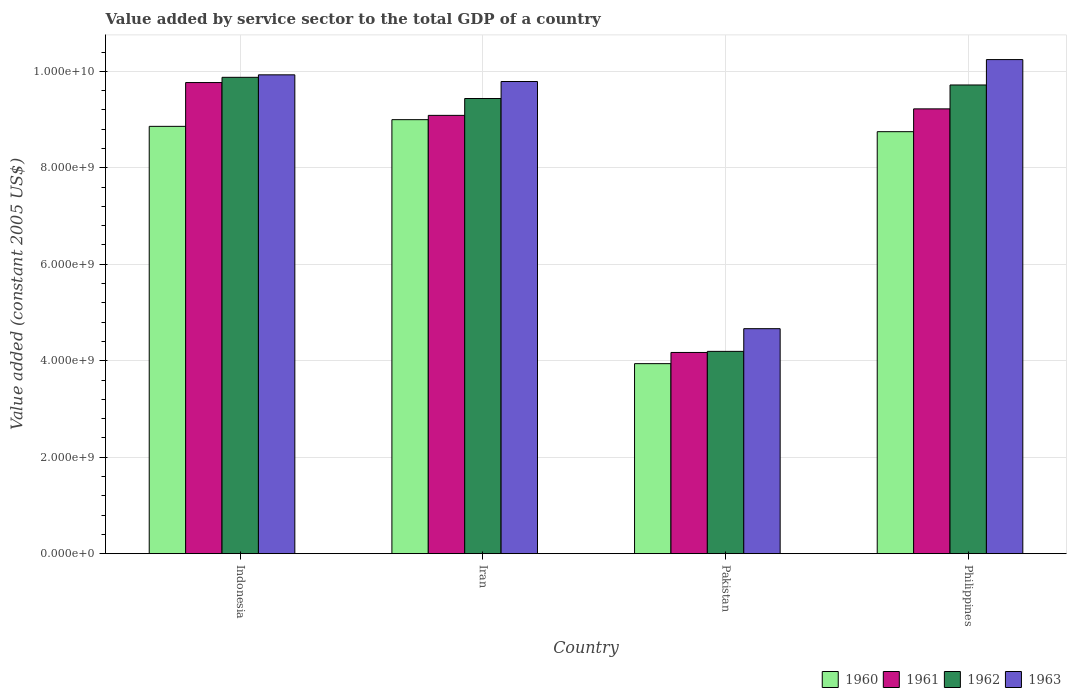How many different coloured bars are there?
Give a very brief answer. 4. How many groups of bars are there?
Your response must be concise. 4. Are the number of bars on each tick of the X-axis equal?
Your answer should be compact. Yes. How many bars are there on the 2nd tick from the left?
Provide a short and direct response. 4. How many bars are there on the 2nd tick from the right?
Offer a terse response. 4. What is the value added by service sector in 1962 in Iran?
Ensure brevity in your answer.  9.44e+09. Across all countries, what is the maximum value added by service sector in 1963?
Ensure brevity in your answer.  1.02e+1. Across all countries, what is the minimum value added by service sector in 1962?
Make the answer very short. 4.19e+09. What is the total value added by service sector in 1962 in the graph?
Offer a terse response. 3.32e+1. What is the difference between the value added by service sector in 1961 in Pakistan and that in Philippines?
Offer a very short reply. -5.05e+09. What is the difference between the value added by service sector in 1960 in Iran and the value added by service sector in 1961 in Pakistan?
Give a very brief answer. 4.83e+09. What is the average value added by service sector in 1960 per country?
Your response must be concise. 7.64e+09. What is the difference between the value added by service sector of/in 1961 and value added by service sector of/in 1960 in Indonesia?
Your answer should be very brief. 9.08e+08. What is the ratio of the value added by service sector in 1961 in Pakistan to that in Philippines?
Ensure brevity in your answer.  0.45. Is the value added by service sector in 1961 in Indonesia less than that in Iran?
Keep it short and to the point. No. Is the difference between the value added by service sector in 1961 in Indonesia and Pakistan greater than the difference between the value added by service sector in 1960 in Indonesia and Pakistan?
Offer a terse response. Yes. What is the difference between the highest and the second highest value added by service sector in 1962?
Your answer should be compact. 2.80e+08. What is the difference between the highest and the lowest value added by service sector in 1962?
Offer a terse response. 5.68e+09. Is the sum of the value added by service sector in 1961 in Iran and Pakistan greater than the maximum value added by service sector in 1963 across all countries?
Make the answer very short. Yes. Is it the case that in every country, the sum of the value added by service sector in 1961 and value added by service sector in 1962 is greater than the sum of value added by service sector in 1960 and value added by service sector in 1963?
Provide a short and direct response. No. What does the 4th bar from the left in Iran represents?
Your response must be concise. 1963. Are all the bars in the graph horizontal?
Keep it short and to the point. No. Does the graph contain any zero values?
Give a very brief answer. No. Does the graph contain grids?
Ensure brevity in your answer.  Yes. Where does the legend appear in the graph?
Your answer should be compact. Bottom right. What is the title of the graph?
Provide a short and direct response. Value added by service sector to the total GDP of a country. What is the label or title of the Y-axis?
Your answer should be compact. Value added (constant 2005 US$). What is the Value added (constant 2005 US$) of 1960 in Indonesia?
Ensure brevity in your answer.  8.86e+09. What is the Value added (constant 2005 US$) in 1961 in Indonesia?
Provide a short and direct response. 9.77e+09. What is the Value added (constant 2005 US$) of 1962 in Indonesia?
Provide a succinct answer. 9.88e+09. What is the Value added (constant 2005 US$) of 1963 in Indonesia?
Offer a terse response. 9.93e+09. What is the Value added (constant 2005 US$) of 1960 in Iran?
Your answer should be very brief. 9.00e+09. What is the Value added (constant 2005 US$) of 1961 in Iran?
Keep it short and to the point. 9.09e+09. What is the Value added (constant 2005 US$) of 1962 in Iran?
Provide a short and direct response. 9.44e+09. What is the Value added (constant 2005 US$) of 1963 in Iran?
Offer a very short reply. 9.79e+09. What is the Value added (constant 2005 US$) of 1960 in Pakistan?
Keep it short and to the point. 3.94e+09. What is the Value added (constant 2005 US$) of 1961 in Pakistan?
Offer a terse response. 4.17e+09. What is the Value added (constant 2005 US$) in 1962 in Pakistan?
Provide a succinct answer. 4.19e+09. What is the Value added (constant 2005 US$) in 1963 in Pakistan?
Provide a short and direct response. 4.66e+09. What is the Value added (constant 2005 US$) of 1960 in Philippines?
Offer a terse response. 8.75e+09. What is the Value added (constant 2005 US$) in 1961 in Philippines?
Your answer should be compact. 9.22e+09. What is the Value added (constant 2005 US$) in 1962 in Philippines?
Keep it short and to the point. 9.72e+09. What is the Value added (constant 2005 US$) of 1963 in Philippines?
Ensure brevity in your answer.  1.02e+1. Across all countries, what is the maximum Value added (constant 2005 US$) of 1960?
Provide a short and direct response. 9.00e+09. Across all countries, what is the maximum Value added (constant 2005 US$) of 1961?
Offer a terse response. 9.77e+09. Across all countries, what is the maximum Value added (constant 2005 US$) of 1962?
Provide a short and direct response. 9.88e+09. Across all countries, what is the maximum Value added (constant 2005 US$) of 1963?
Keep it short and to the point. 1.02e+1. Across all countries, what is the minimum Value added (constant 2005 US$) in 1960?
Your answer should be very brief. 3.94e+09. Across all countries, what is the minimum Value added (constant 2005 US$) in 1961?
Your answer should be very brief. 4.17e+09. Across all countries, what is the minimum Value added (constant 2005 US$) in 1962?
Make the answer very short. 4.19e+09. Across all countries, what is the minimum Value added (constant 2005 US$) in 1963?
Give a very brief answer. 4.66e+09. What is the total Value added (constant 2005 US$) in 1960 in the graph?
Keep it short and to the point. 3.05e+1. What is the total Value added (constant 2005 US$) in 1961 in the graph?
Give a very brief answer. 3.22e+1. What is the total Value added (constant 2005 US$) in 1962 in the graph?
Give a very brief answer. 3.32e+1. What is the total Value added (constant 2005 US$) in 1963 in the graph?
Give a very brief answer. 3.46e+1. What is the difference between the Value added (constant 2005 US$) of 1960 in Indonesia and that in Iran?
Provide a short and direct response. -1.39e+08. What is the difference between the Value added (constant 2005 US$) of 1961 in Indonesia and that in Iran?
Your response must be concise. 6.80e+08. What is the difference between the Value added (constant 2005 US$) in 1962 in Indonesia and that in Iran?
Offer a very short reply. 4.39e+08. What is the difference between the Value added (constant 2005 US$) in 1963 in Indonesia and that in Iran?
Give a very brief answer. 1.38e+08. What is the difference between the Value added (constant 2005 US$) in 1960 in Indonesia and that in Pakistan?
Offer a very short reply. 4.92e+09. What is the difference between the Value added (constant 2005 US$) of 1961 in Indonesia and that in Pakistan?
Offer a terse response. 5.60e+09. What is the difference between the Value added (constant 2005 US$) of 1962 in Indonesia and that in Pakistan?
Ensure brevity in your answer.  5.68e+09. What is the difference between the Value added (constant 2005 US$) of 1963 in Indonesia and that in Pakistan?
Give a very brief answer. 5.26e+09. What is the difference between the Value added (constant 2005 US$) in 1960 in Indonesia and that in Philippines?
Your answer should be very brief. 1.10e+08. What is the difference between the Value added (constant 2005 US$) of 1961 in Indonesia and that in Philippines?
Your answer should be compact. 5.45e+08. What is the difference between the Value added (constant 2005 US$) in 1962 in Indonesia and that in Philippines?
Make the answer very short. 1.59e+08. What is the difference between the Value added (constant 2005 US$) of 1963 in Indonesia and that in Philippines?
Your answer should be very brief. -3.16e+08. What is the difference between the Value added (constant 2005 US$) in 1960 in Iran and that in Pakistan?
Provide a short and direct response. 5.06e+09. What is the difference between the Value added (constant 2005 US$) in 1961 in Iran and that in Pakistan?
Your response must be concise. 4.92e+09. What is the difference between the Value added (constant 2005 US$) in 1962 in Iran and that in Pakistan?
Keep it short and to the point. 5.24e+09. What is the difference between the Value added (constant 2005 US$) in 1963 in Iran and that in Pakistan?
Provide a short and direct response. 5.12e+09. What is the difference between the Value added (constant 2005 US$) of 1960 in Iran and that in Philippines?
Your response must be concise. 2.49e+08. What is the difference between the Value added (constant 2005 US$) of 1961 in Iran and that in Philippines?
Make the answer very short. -1.35e+08. What is the difference between the Value added (constant 2005 US$) of 1962 in Iran and that in Philippines?
Keep it short and to the point. -2.80e+08. What is the difference between the Value added (constant 2005 US$) in 1963 in Iran and that in Philippines?
Ensure brevity in your answer.  -4.54e+08. What is the difference between the Value added (constant 2005 US$) of 1960 in Pakistan and that in Philippines?
Provide a succinct answer. -4.81e+09. What is the difference between the Value added (constant 2005 US$) of 1961 in Pakistan and that in Philippines?
Your answer should be very brief. -5.05e+09. What is the difference between the Value added (constant 2005 US$) in 1962 in Pakistan and that in Philippines?
Provide a succinct answer. -5.52e+09. What is the difference between the Value added (constant 2005 US$) in 1963 in Pakistan and that in Philippines?
Offer a terse response. -5.58e+09. What is the difference between the Value added (constant 2005 US$) in 1960 in Indonesia and the Value added (constant 2005 US$) in 1961 in Iran?
Your answer should be very brief. -2.28e+08. What is the difference between the Value added (constant 2005 US$) in 1960 in Indonesia and the Value added (constant 2005 US$) in 1962 in Iran?
Give a very brief answer. -5.77e+08. What is the difference between the Value added (constant 2005 US$) in 1960 in Indonesia and the Value added (constant 2005 US$) in 1963 in Iran?
Keep it short and to the point. -9.30e+08. What is the difference between the Value added (constant 2005 US$) in 1961 in Indonesia and the Value added (constant 2005 US$) in 1962 in Iran?
Provide a short and direct response. 3.30e+08. What is the difference between the Value added (constant 2005 US$) in 1961 in Indonesia and the Value added (constant 2005 US$) in 1963 in Iran?
Your response must be concise. -2.20e+07. What is the difference between the Value added (constant 2005 US$) in 1962 in Indonesia and the Value added (constant 2005 US$) in 1963 in Iran?
Ensure brevity in your answer.  8.67e+07. What is the difference between the Value added (constant 2005 US$) of 1960 in Indonesia and the Value added (constant 2005 US$) of 1961 in Pakistan?
Provide a short and direct response. 4.69e+09. What is the difference between the Value added (constant 2005 US$) in 1960 in Indonesia and the Value added (constant 2005 US$) in 1962 in Pakistan?
Ensure brevity in your answer.  4.66e+09. What is the difference between the Value added (constant 2005 US$) of 1960 in Indonesia and the Value added (constant 2005 US$) of 1963 in Pakistan?
Keep it short and to the point. 4.19e+09. What is the difference between the Value added (constant 2005 US$) in 1961 in Indonesia and the Value added (constant 2005 US$) in 1962 in Pakistan?
Offer a terse response. 5.57e+09. What is the difference between the Value added (constant 2005 US$) of 1961 in Indonesia and the Value added (constant 2005 US$) of 1963 in Pakistan?
Make the answer very short. 5.10e+09. What is the difference between the Value added (constant 2005 US$) of 1962 in Indonesia and the Value added (constant 2005 US$) of 1963 in Pakistan?
Offer a terse response. 5.21e+09. What is the difference between the Value added (constant 2005 US$) in 1960 in Indonesia and the Value added (constant 2005 US$) in 1961 in Philippines?
Provide a succinct answer. -3.63e+08. What is the difference between the Value added (constant 2005 US$) of 1960 in Indonesia and the Value added (constant 2005 US$) of 1962 in Philippines?
Your answer should be very brief. -8.58e+08. What is the difference between the Value added (constant 2005 US$) of 1960 in Indonesia and the Value added (constant 2005 US$) of 1963 in Philippines?
Give a very brief answer. -1.38e+09. What is the difference between the Value added (constant 2005 US$) in 1961 in Indonesia and the Value added (constant 2005 US$) in 1962 in Philippines?
Keep it short and to the point. 5.00e+07. What is the difference between the Value added (constant 2005 US$) of 1961 in Indonesia and the Value added (constant 2005 US$) of 1963 in Philippines?
Provide a succinct answer. -4.76e+08. What is the difference between the Value added (constant 2005 US$) in 1962 in Indonesia and the Value added (constant 2005 US$) in 1963 in Philippines?
Provide a succinct answer. -3.68e+08. What is the difference between the Value added (constant 2005 US$) of 1960 in Iran and the Value added (constant 2005 US$) of 1961 in Pakistan?
Your response must be concise. 4.83e+09. What is the difference between the Value added (constant 2005 US$) of 1960 in Iran and the Value added (constant 2005 US$) of 1962 in Pakistan?
Your response must be concise. 4.80e+09. What is the difference between the Value added (constant 2005 US$) in 1960 in Iran and the Value added (constant 2005 US$) in 1963 in Pakistan?
Offer a very short reply. 4.33e+09. What is the difference between the Value added (constant 2005 US$) in 1961 in Iran and the Value added (constant 2005 US$) in 1962 in Pakistan?
Offer a terse response. 4.89e+09. What is the difference between the Value added (constant 2005 US$) in 1961 in Iran and the Value added (constant 2005 US$) in 1963 in Pakistan?
Provide a succinct answer. 4.42e+09. What is the difference between the Value added (constant 2005 US$) of 1962 in Iran and the Value added (constant 2005 US$) of 1963 in Pakistan?
Provide a short and direct response. 4.77e+09. What is the difference between the Value added (constant 2005 US$) in 1960 in Iran and the Value added (constant 2005 US$) in 1961 in Philippines?
Provide a short and direct response. -2.24e+08. What is the difference between the Value added (constant 2005 US$) of 1960 in Iran and the Value added (constant 2005 US$) of 1962 in Philippines?
Provide a short and direct response. -7.19e+08. What is the difference between the Value added (constant 2005 US$) in 1960 in Iran and the Value added (constant 2005 US$) in 1963 in Philippines?
Offer a very short reply. -1.25e+09. What is the difference between the Value added (constant 2005 US$) in 1961 in Iran and the Value added (constant 2005 US$) in 1962 in Philippines?
Your answer should be very brief. -6.30e+08. What is the difference between the Value added (constant 2005 US$) of 1961 in Iran and the Value added (constant 2005 US$) of 1963 in Philippines?
Your answer should be compact. -1.16e+09. What is the difference between the Value added (constant 2005 US$) of 1962 in Iran and the Value added (constant 2005 US$) of 1963 in Philippines?
Give a very brief answer. -8.07e+08. What is the difference between the Value added (constant 2005 US$) in 1960 in Pakistan and the Value added (constant 2005 US$) in 1961 in Philippines?
Ensure brevity in your answer.  -5.28e+09. What is the difference between the Value added (constant 2005 US$) in 1960 in Pakistan and the Value added (constant 2005 US$) in 1962 in Philippines?
Offer a terse response. -5.78e+09. What is the difference between the Value added (constant 2005 US$) in 1960 in Pakistan and the Value added (constant 2005 US$) in 1963 in Philippines?
Your response must be concise. -6.30e+09. What is the difference between the Value added (constant 2005 US$) in 1961 in Pakistan and the Value added (constant 2005 US$) in 1962 in Philippines?
Give a very brief answer. -5.55e+09. What is the difference between the Value added (constant 2005 US$) in 1961 in Pakistan and the Value added (constant 2005 US$) in 1963 in Philippines?
Ensure brevity in your answer.  -6.07e+09. What is the difference between the Value added (constant 2005 US$) in 1962 in Pakistan and the Value added (constant 2005 US$) in 1963 in Philippines?
Give a very brief answer. -6.05e+09. What is the average Value added (constant 2005 US$) of 1960 per country?
Your answer should be compact. 7.64e+09. What is the average Value added (constant 2005 US$) of 1961 per country?
Ensure brevity in your answer.  8.06e+09. What is the average Value added (constant 2005 US$) of 1962 per country?
Your answer should be compact. 8.31e+09. What is the average Value added (constant 2005 US$) of 1963 per country?
Your answer should be compact. 8.66e+09. What is the difference between the Value added (constant 2005 US$) in 1960 and Value added (constant 2005 US$) in 1961 in Indonesia?
Offer a terse response. -9.08e+08. What is the difference between the Value added (constant 2005 US$) in 1960 and Value added (constant 2005 US$) in 1962 in Indonesia?
Your answer should be compact. -1.02e+09. What is the difference between the Value added (constant 2005 US$) in 1960 and Value added (constant 2005 US$) in 1963 in Indonesia?
Provide a succinct answer. -1.07e+09. What is the difference between the Value added (constant 2005 US$) of 1961 and Value added (constant 2005 US$) of 1962 in Indonesia?
Offer a terse response. -1.09e+08. What is the difference between the Value added (constant 2005 US$) of 1961 and Value added (constant 2005 US$) of 1963 in Indonesia?
Give a very brief answer. -1.60e+08. What is the difference between the Value added (constant 2005 US$) in 1962 and Value added (constant 2005 US$) in 1963 in Indonesia?
Make the answer very short. -5.15e+07. What is the difference between the Value added (constant 2005 US$) of 1960 and Value added (constant 2005 US$) of 1961 in Iran?
Offer a very short reply. -8.88e+07. What is the difference between the Value added (constant 2005 US$) of 1960 and Value added (constant 2005 US$) of 1962 in Iran?
Make the answer very short. -4.39e+08. What is the difference between the Value added (constant 2005 US$) of 1960 and Value added (constant 2005 US$) of 1963 in Iran?
Your response must be concise. -7.91e+08. What is the difference between the Value added (constant 2005 US$) of 1961 and Value added (constant 2005 US$) of 1962 in Iran?
Keep it short and to the point. -3.50e+08. What is the difference between the Value added (constant 2005 US$) of 1961 and Value added (constant 2005 US$) of 1963 in Iran?
Keep it short and to the point. -7.02e+08. What is the difference between the Value added (constant 2005 US$) in 1962 and Value added (constant 2005 US$) in 1963 in Iran?
Provide a short and direct response. -3.52e+08. What is the difference between the Value added (constant 2005 US$) of 1960 and Value added (constant 2005 US$) of 1961 in Pakistan?
Your response must be concise. -2.32e+08. What is the difference between the Value added (constant 2005 US$) in 1960 and Value added (constant 2005 US$) in 1962 in Pakistan?
Offer a very short reply. -2.54e+08. What is the difference between the Value added (constant 2005 US$) in 1960 and Value added (constant 2005 US$) in 1963 in Pakistan?
Provide a short and direct response. -7.25e+08. What is the difference between the Value added (constant 2005 US$) of 1961 and Value added (constant 2005 US$) of 1962 in Pakistan?
Offer a very short reply. -2.26e+07. What is the difference between the Value added (constant 2005 US$) in 1961 and Value added (constant 2005 US$) in 1963 in Pakistan?
Your response must be concise. -4.93e+08. What is the difference between the Value added (constant 2005 US$) of 1962 and Value added (constant 2005 US$) of 1963 in Pakistan?
Keep it short and to the point. -4.71e+08. What is the difference between the Value added (constant 2005 US$) of 1960 and Value added (constant 2005 US$) of 1961 in Philippines?
Your answer should be compact. -4.73e+08. What is the difference between the Value added (constant 2005 US$) in 1960 and Value added (constant 2005 US$) in 1962 in Philippines?
Ensure brevity in your answer.  -9.68e+08. What is the difference between the Value added (constant 2005 US$) of 1960 and Value added (constant 2005 US$) of 1963 in Philippines?
Provide a succinct answer. -1.49e+09. What is the difference between the Value added (constant 2005 US$) of 1961 and Value added (constant 2005 US$) of 1962 in Philippines?
Provide a short and direct response. -4.95e+08. What is the difference between the Value added (constant 2005 US$) in 1961 and Value added (constant 2005 US$) in 1963 in Philippines?
Provide a short and direct response. -1.02e+09. What is the difference between the Value added (constant 2005 US$) of 1962 and Value added (constant 2005 US$) of 1963 in Philippines?
Provide a short and direct response. -5.27e+08. What is the ratio of the Value added (constant 2005 US$) of 1960 in Indonesia to that in Iran?
Offer a terse response. 0.98. What is the ratio of the Value added (constant 2005 US$) in 1961 in Indonesia to that in Iran?
Make the answer very short. 1.07. What is the ratio of the Value added (constant 2005 US$) in 1962 in Indonesia to that in Iran?
Provide a succinct answer. 1.05. What is the ratio of the Value added (constant 2005 US$) of 1963 in Indonesia to that in Iran?
Offer a very short reply. 1.01. What is the ratio of the Value added (constant 2005 US$) of 1960 in Indonesia to that in Pakistan?
Your response must be concise. 2.25. What is the ratio of the Value added (constant 2005 US$) of 1961 in Indonesia to that in Pakistan?
Your answer should be compact. 2.34. What is the ratio of the Value added (constant 2005 US$) in 1962 in Indonesia to that in Pakistan?
Ensure brevity in your answer.  2.35. What is the ratio of the Value added (constant 2005 US$) of 1963 in Indonesia to that in Pakistan?
Your answer should be very brief. 2.13. What is the ratio of the Value added (constant 2005 US$) in 1960 in Indonesia to that in Philippines?
Provide a succinct answer. 1.01. What is the ratio of the Value added (constant 2005 US$) in 1961 in Indonesia to that in Philippines?
Offer a terse response. 1.06. What is the ratio of the Value added (constant 2005 US$) of 1962 in Indonesia to that in Philippines?
Offer a very short reply. 1.02. What is the ratio of the Value added (constant 2005 US$) of 1963 in Indonesia to that in Philippines?
Your answer should be compact. 0.97. What is the ratio of the Value added (constant 2005 US$) in 1960 in Iran to that in Pakistan?
Ensure brevity in your answer.  2.28. What is the ratio of the Value added (constant 2005 US$) of 1961 in Iran to that in Pakistan?
Your answer should be very brief. 2.18. What is the ratio of the Value added (constant 2005 US$) of 1962 in Iran to that in Pakistan?
Keep it short and to the point. 2.25. What is the ratio of the Value added (constant 2005 US$) of 1963 in Iran to that in Pakistan?
Keep it short and to the point. 2.1. What is the ratio of the Value added (constant 2005 US$) of 1960 in Iran to that in Philippines?
Offer a very short reply. 1.03. What is the ratio of the Value added (constant 2005 US$) in 1961 in Iran to that in Philippines?
Offer a very short reply. 0.99. What is the ratio of the Value added (constant 2005 US$) in 1962 in Iran to that in Philippines?
Offer a terse response. 0.97. What is the ratio of the Value added (constant 2005 US$) of 1963 in Iran to that in Philippines?
Offer a terse response. 0.96. What is the ratio of the Value added (constant 2005 US$) in 1960 in Pakistan to that in Philippines?
Make the answer very short. 0.45. What is the ratio of the Value added (constant 2005 US$) in 1961 in Pakistan to that in Philippines?
Make the answer very short. 0.45. What is the ratio of the Value added (constant 2005 US$) in 1962 in Pakistan to that in Philippines?
Provide a short and direct response. 0.43. What is the ratio of the Value added (constant 2005 US$) of 1963 in Pakistan to that in Philippines?
Your answer should be very brief. 0.46. What is the difference between the highest and the second highest Value added (constant 2005 US$) in 1960?
Your answer should be compact. 1.39e+08. What is the difference between the highest and the second highest Value added (constant 2005 US$) of 1961?
Your answer should be very brief. 5.45e+08. What is the difference between the highest and the second highest Value added (constant 2005 US$) in 1962?
Ensure brevity in your answer.  1.59e+08. What is the difference between the highest and the second highest Value added (constant 2005 US$) in 1963?
Give a very brief answer. 3.16e+08. What is the difference between the highest and the lowest Value added (constant 2005 US$) of 1960?
Offer a terse response. 5.06e+09. What is the difference between the highest and the lowest Value added (constant 2005 US$) in 1961?
Offer a terse response. 5.60e+09. What is the difference between the highest and the lowest Value added (constant 2005 US$) of 1962?
Provide a succinct answer. 5.68e+09. What is the difference between the highest and the lowest Value added (constant 2005 US$) of 1963?
Offer a terse response. 5.58e+09. 